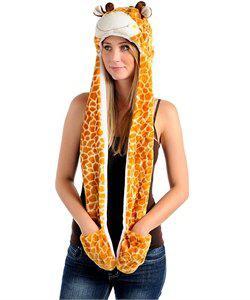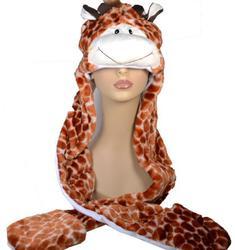The first image is the image on the left, the second image is the image on the right. Given the left and right images, does the statement "a person has one hand tucked in a hat pocket" hold true? Answer yes or no. No. The first image is the image on the left, the second image is the image on the right. Assess this claim about the two images: "At least one of the hats has a giraffe print.". Correct or not? Answer yes or no. Yes. 